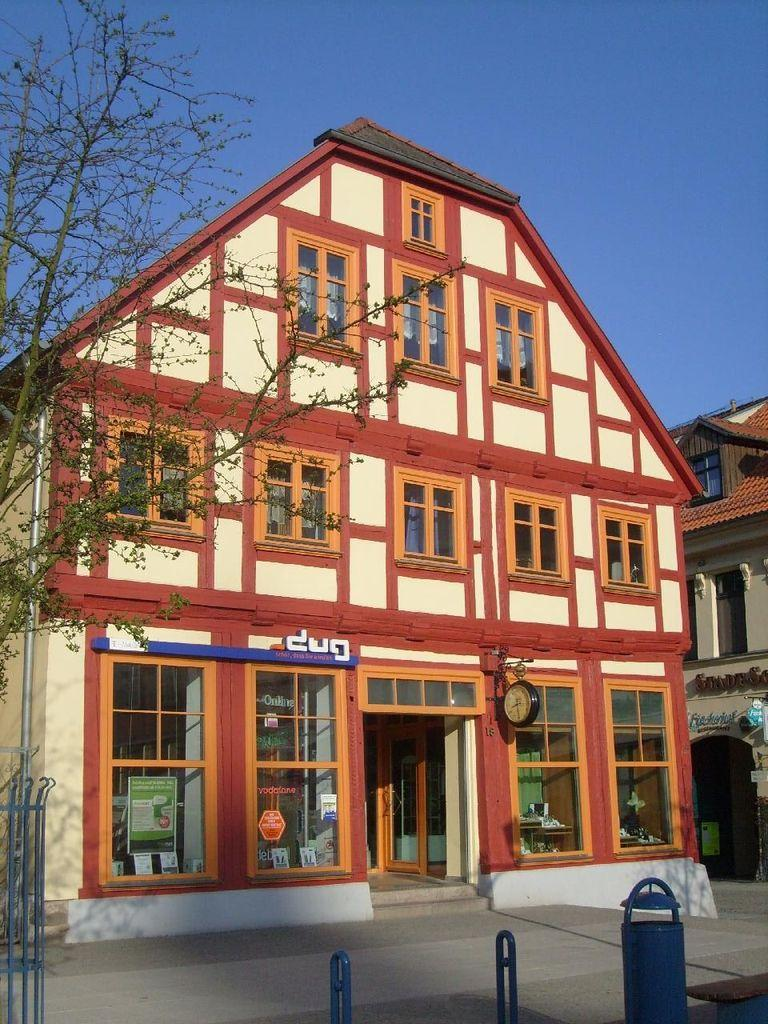What type of structure is visible in the image? There is a house in the image. What is located in front of the house? There is a road in front of the house. What can be seen at the bottom of the image? There is a stand at the bottom of the image. What is visible at the top of the image? The sky is visible at the top of the image. What other structure is present in the image? There is another building on the right side of the image. Can you tell me where the aunt's locket is located in the image? There is no mention of an aunt or a locket in the image, so we cannot determine its location. 